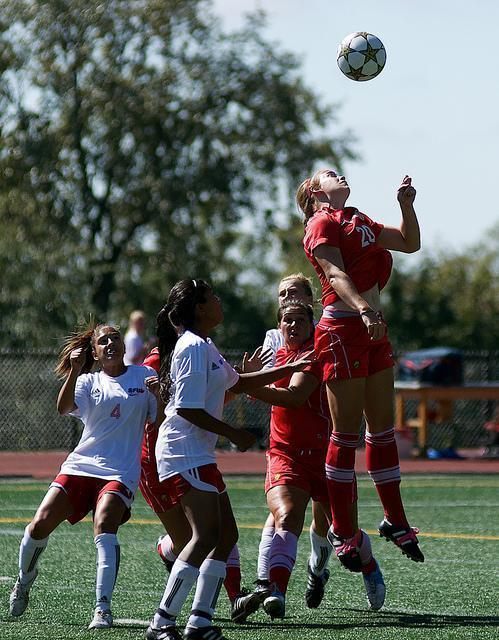How many people are there?
Give a very brief answer. 5. How many red bikes are there?
Give a very brief answer. 0. 